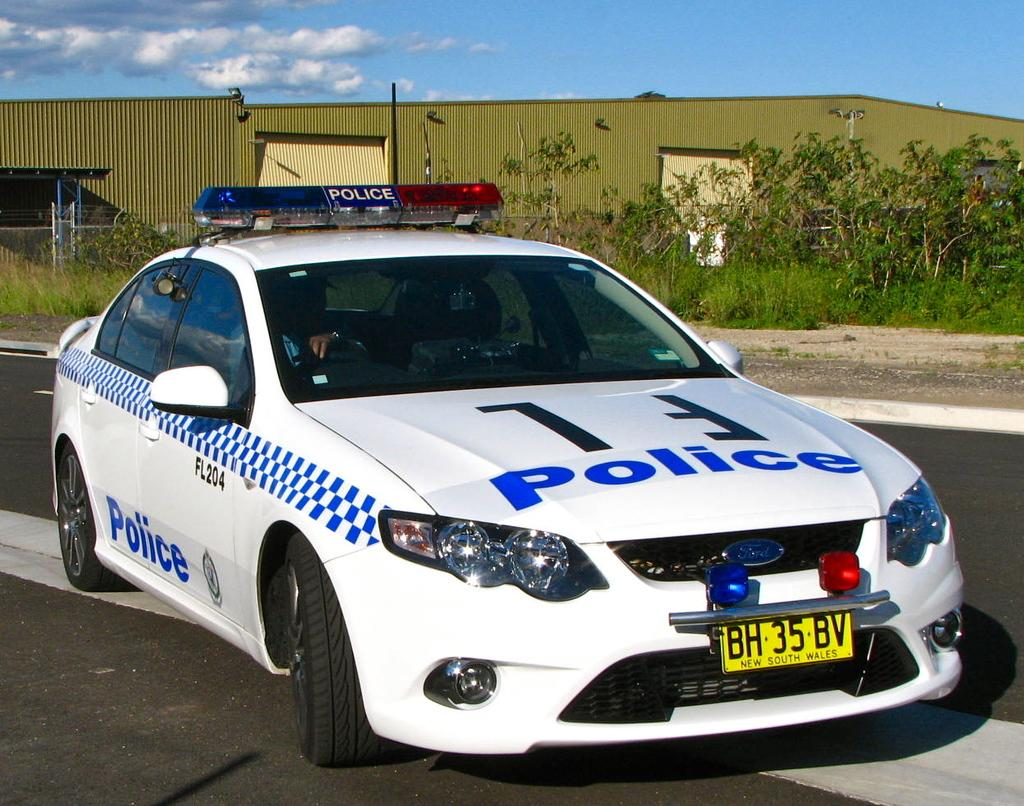What is the main subject in the foreground of the image? There is a car in the foreground of the image. Where is the car located? The car is on the road. What can be seen in the background of the image? There are trees, grass, fencing, a building, and the sky visible in the background of the image. What type of soap is being used to clean the car in the image? There is no soap present in the image, and the car is not being cleaned. Can you see any railway tracks in the image? There are no railway tracks visible in the image. 